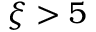Convert formula to latex. <formula><loc_0><loc_0><loc_500><loc_500>\xi > 5</formula> 